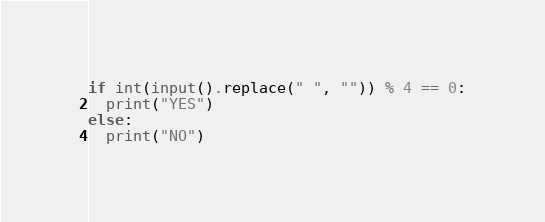<code> <loc_0><loc_0><loc_500><loc_500><_Python_>if int(input().replace(" ", "")) % 4 == 0:
  print("YES")
else:
  print("NO")</code> 